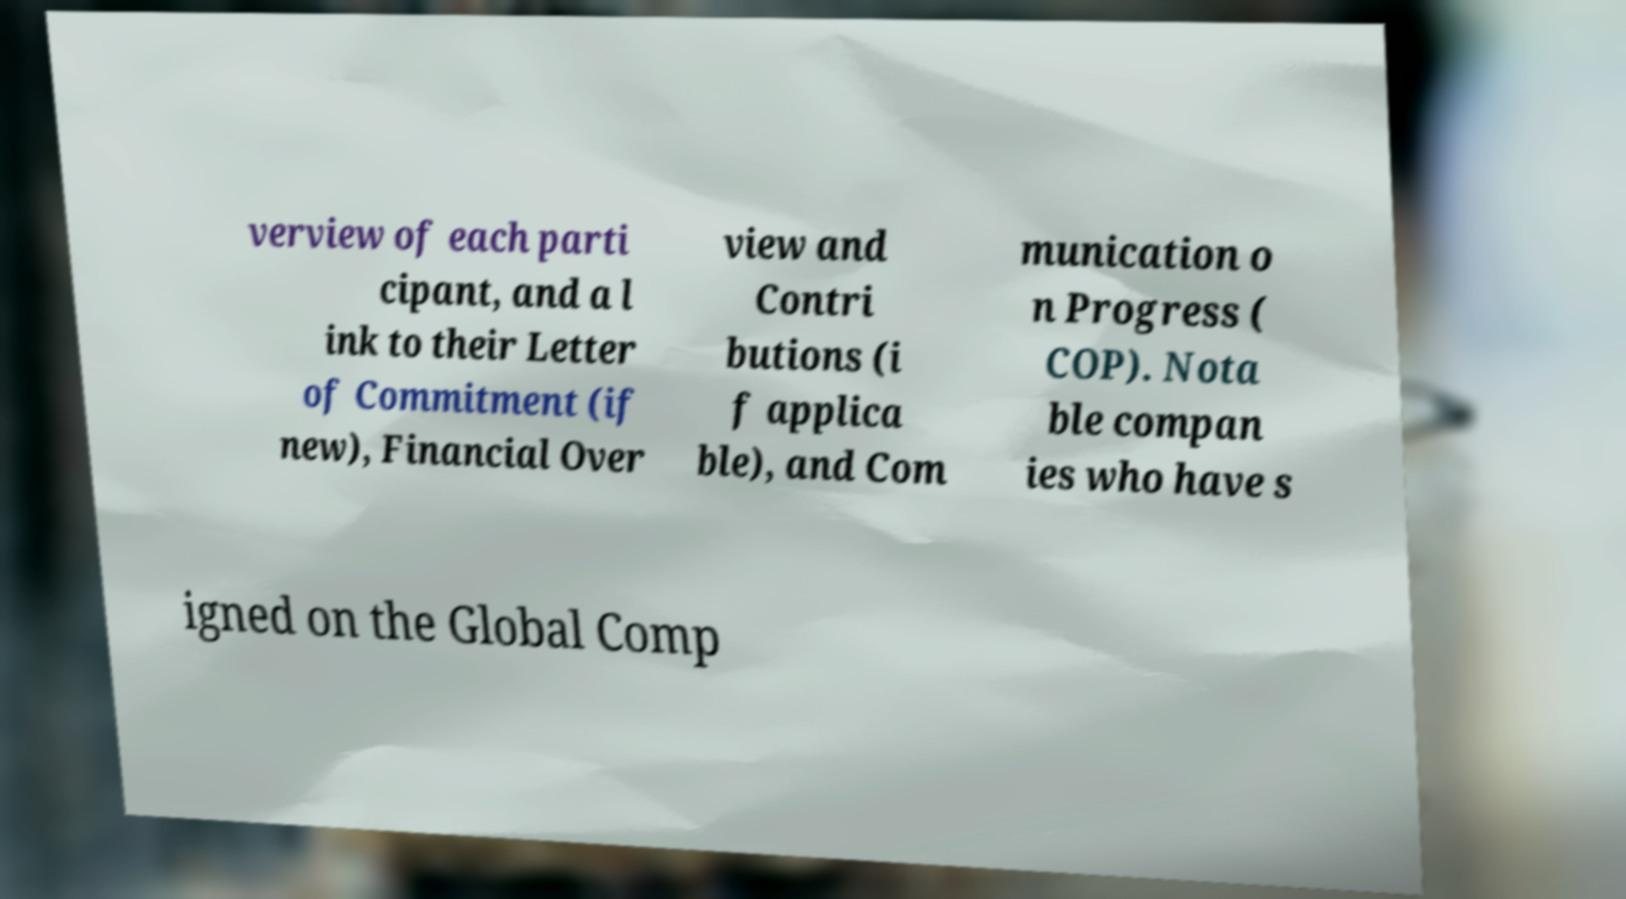Please read and relay the text visible in this image. What does it say? verview of each parti cipant, and a l ink to their Letter of Commitment (if new), Financial Over view and Contri butions (i f applica ble), and Com munication o n Progress ( COP). Nota ble compan ies who have s igned on the Global Comp 